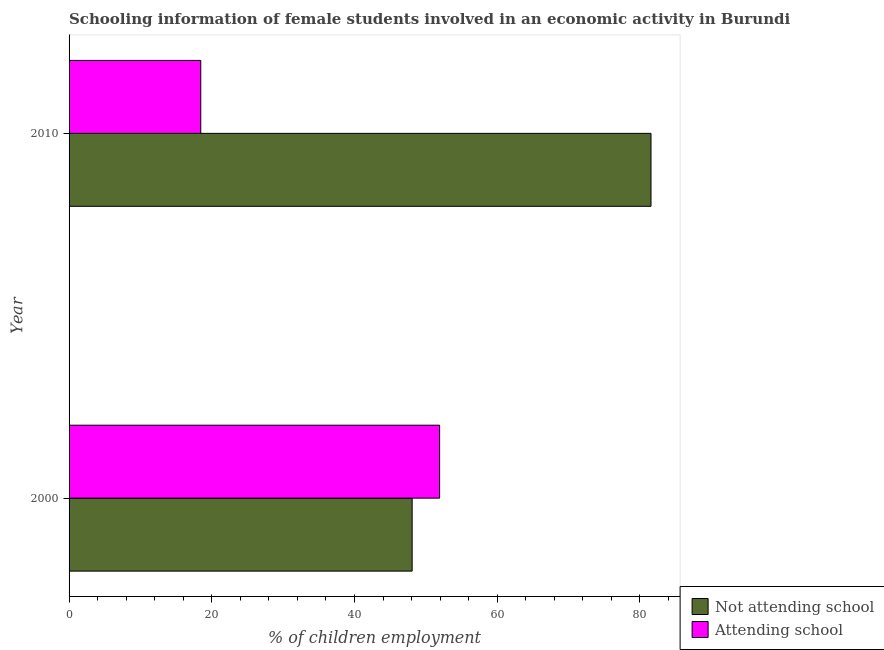How many different coloured bars are there?
Provide a short and direct response. 2. How many groups of bars are there?
Offer a terse response. 2. Are the number of bars per tick equal to the number of legend labels?
Give a very brief answer. Yes. How many bars are there on the 1st tick from the top?
Offer a very short reply. 2. How many bars are there on the 2nd tick from the bottom?
Provide a succinct answer. 2. What is the label of the 1st group of bars from the top?
Make the answer very short. 2010. In how many cases, is the number of bars for a given year not equal to the number of legend labels?
Keep it short and to the point. 0. What is the percentage of employed females who are attending school in 2000?
Give a very brief answer. 51.93. Across all years, what is the maximum percentage of employed females who are not attending school?
Ensure brevity in your answer.  81.54. Across all years, what is the minimum percentage of employed females who are attending school?
Provide a succinct answer. 18.46. In which year was the percentage of employed females who are attending school minimum?
Offer a very short reply. 2010. What is the total percentage of employed females who are attending school in the graph?
Offer a very short reply. 70.38. What is the difference between the percentage of employed females who are attending school in 2000 and that in 2010?
Give a very brief answer. 33.47. What is the difference between the percentage of employed females who are attending school in 2010 and the percentage of employed females who are not attending school in 2000?
Your answer should be very brief. -29.62. What is the average percentage of employed females who are attending school per year?
Your answer should be compact. 35.19. In the year 2010, what is the difference between the percentage of employed females who are not attending school and percentage of employed females who are attending school?
Offer a terse response. 63.09. In how many years, is the percentage of employed females who are not attending school greater than 20 %?
Give a very brief answer. 2. What is the ratio of the percentage of employed females who are attending school in 2000 to that in 2010?
Give a very brief answer. 2.81. Is the difference between the percentage of employed females who are not attending school in 2000 and 2010 greater than the difference between the percentage of employed females who are attending school in 2000 and 2010?
Provide a short and direct response. No. In how many years, is the percentage of employed females who are not attending school greater than the average percentage of employed females who are not attending school taken over all years?
Your response must be concise. 1. What does the 2nd bar from the top in 2000 represents?
Offer a terse response. Not attending school. What does the 1st bar from the bottom in 2000 represents?
Provide a succinct answer. Not attending school. How many bars are there?
Give a very brief answer. 4. Are all the bars in the graph horizontal?
Keep it short and to the point. Yes. Are the values on the major ticks of X-axis written in scientific E-notation?
Provide a succinct answer. No. Does the graph contain grids?
Provide a succinct answer. No. How many legend labels are there?
Keep it short and to the point. 2. What is the title of the graph?
Give a very brief answer. Schooling information of female students involved in an economic activity in Burundi. What is the label or title of the X-axis?
Provide a short and direct response. % of children employment. What is the % of children employment in Not attending school in 2000?
Offer a terse response. 48.07. What is the % of children employment in Attending school in 2000?
Give a very brief answer. 51.93. What is the % of children employment of Not attending school in 2010?
Give a very brief answer. 81.54. What is the % of children employment in Attending school in 2010?
Give a very brief answer. 18.46. Across all years, what is the maximum % of children employment of Not attending school?
Offer a terse response. 81.54. Across all years, what is the maximum % of children employment in Attending school?
Your answer should be very brief. 51.93. Across all years, what is the minimum % of children employment of Not attending school?
Your response must be concise. 48.07. Across all years, what is the minimum % of children employment in Attending school?
Make the answer very short. 18.46. What is the total % of children employment in Not attending school in the graph?
Your answer should be compact. 129.62. What is the total % of children employment in Attending school in the graph?
Your answer should be very brief. 70.38. What is the difference between the % of children employment in Not attending school in 2000 and that in 2010?
Give a very brief answer. -33.47. What is the difference between the % of children employment of Attending school in 2000 and that in 2010?
Offer a terse response. 33.47. What is the difference between the % of children employment of Not attending school in 2000 and the % of children employment of Attending school in 2010?
Ensure brevity in your answer.  29.62. What is the average % of children employment in Not attending school per year?
Ensure brevity in your answer.  64.81. What is the average % of children employment of Attending school per year?
Provide a short and direct response. 35.19. In the year 2000, what is the difference between the % of children employment of Not attending school and % of children employment of Attending school?
Keep it short and to the point. -3.85. In the year 2010, what is the difference between the % of children employment of Not attending school and % of children employment of Attending school?
Keep it short and to the point. 63.09. What is the ratio of the % of children employment in Not attending school in 2000 to that in 2010?
Provide a short and direct response. 0.59. What is the ratio of the % of children employment of Attending school in 2000 to that in 2010?
Offer a very short reply. 2.81. What is the difference between the highest and the second highest % of children employment in Not attending school?
Your answer should be very brief. 33.47. What is the difference between the highest and the second highest % of children employment in Attending school?
Provide a short and direct response. 33.47. What is the difference between the highest and the lowest % of children employment in Not attending school?
Your answer should be very brief. 33.47. What is the difference between the highest and the lowest % of children employment of Attending school?
Ensure brevity in your answer.  33.47. 